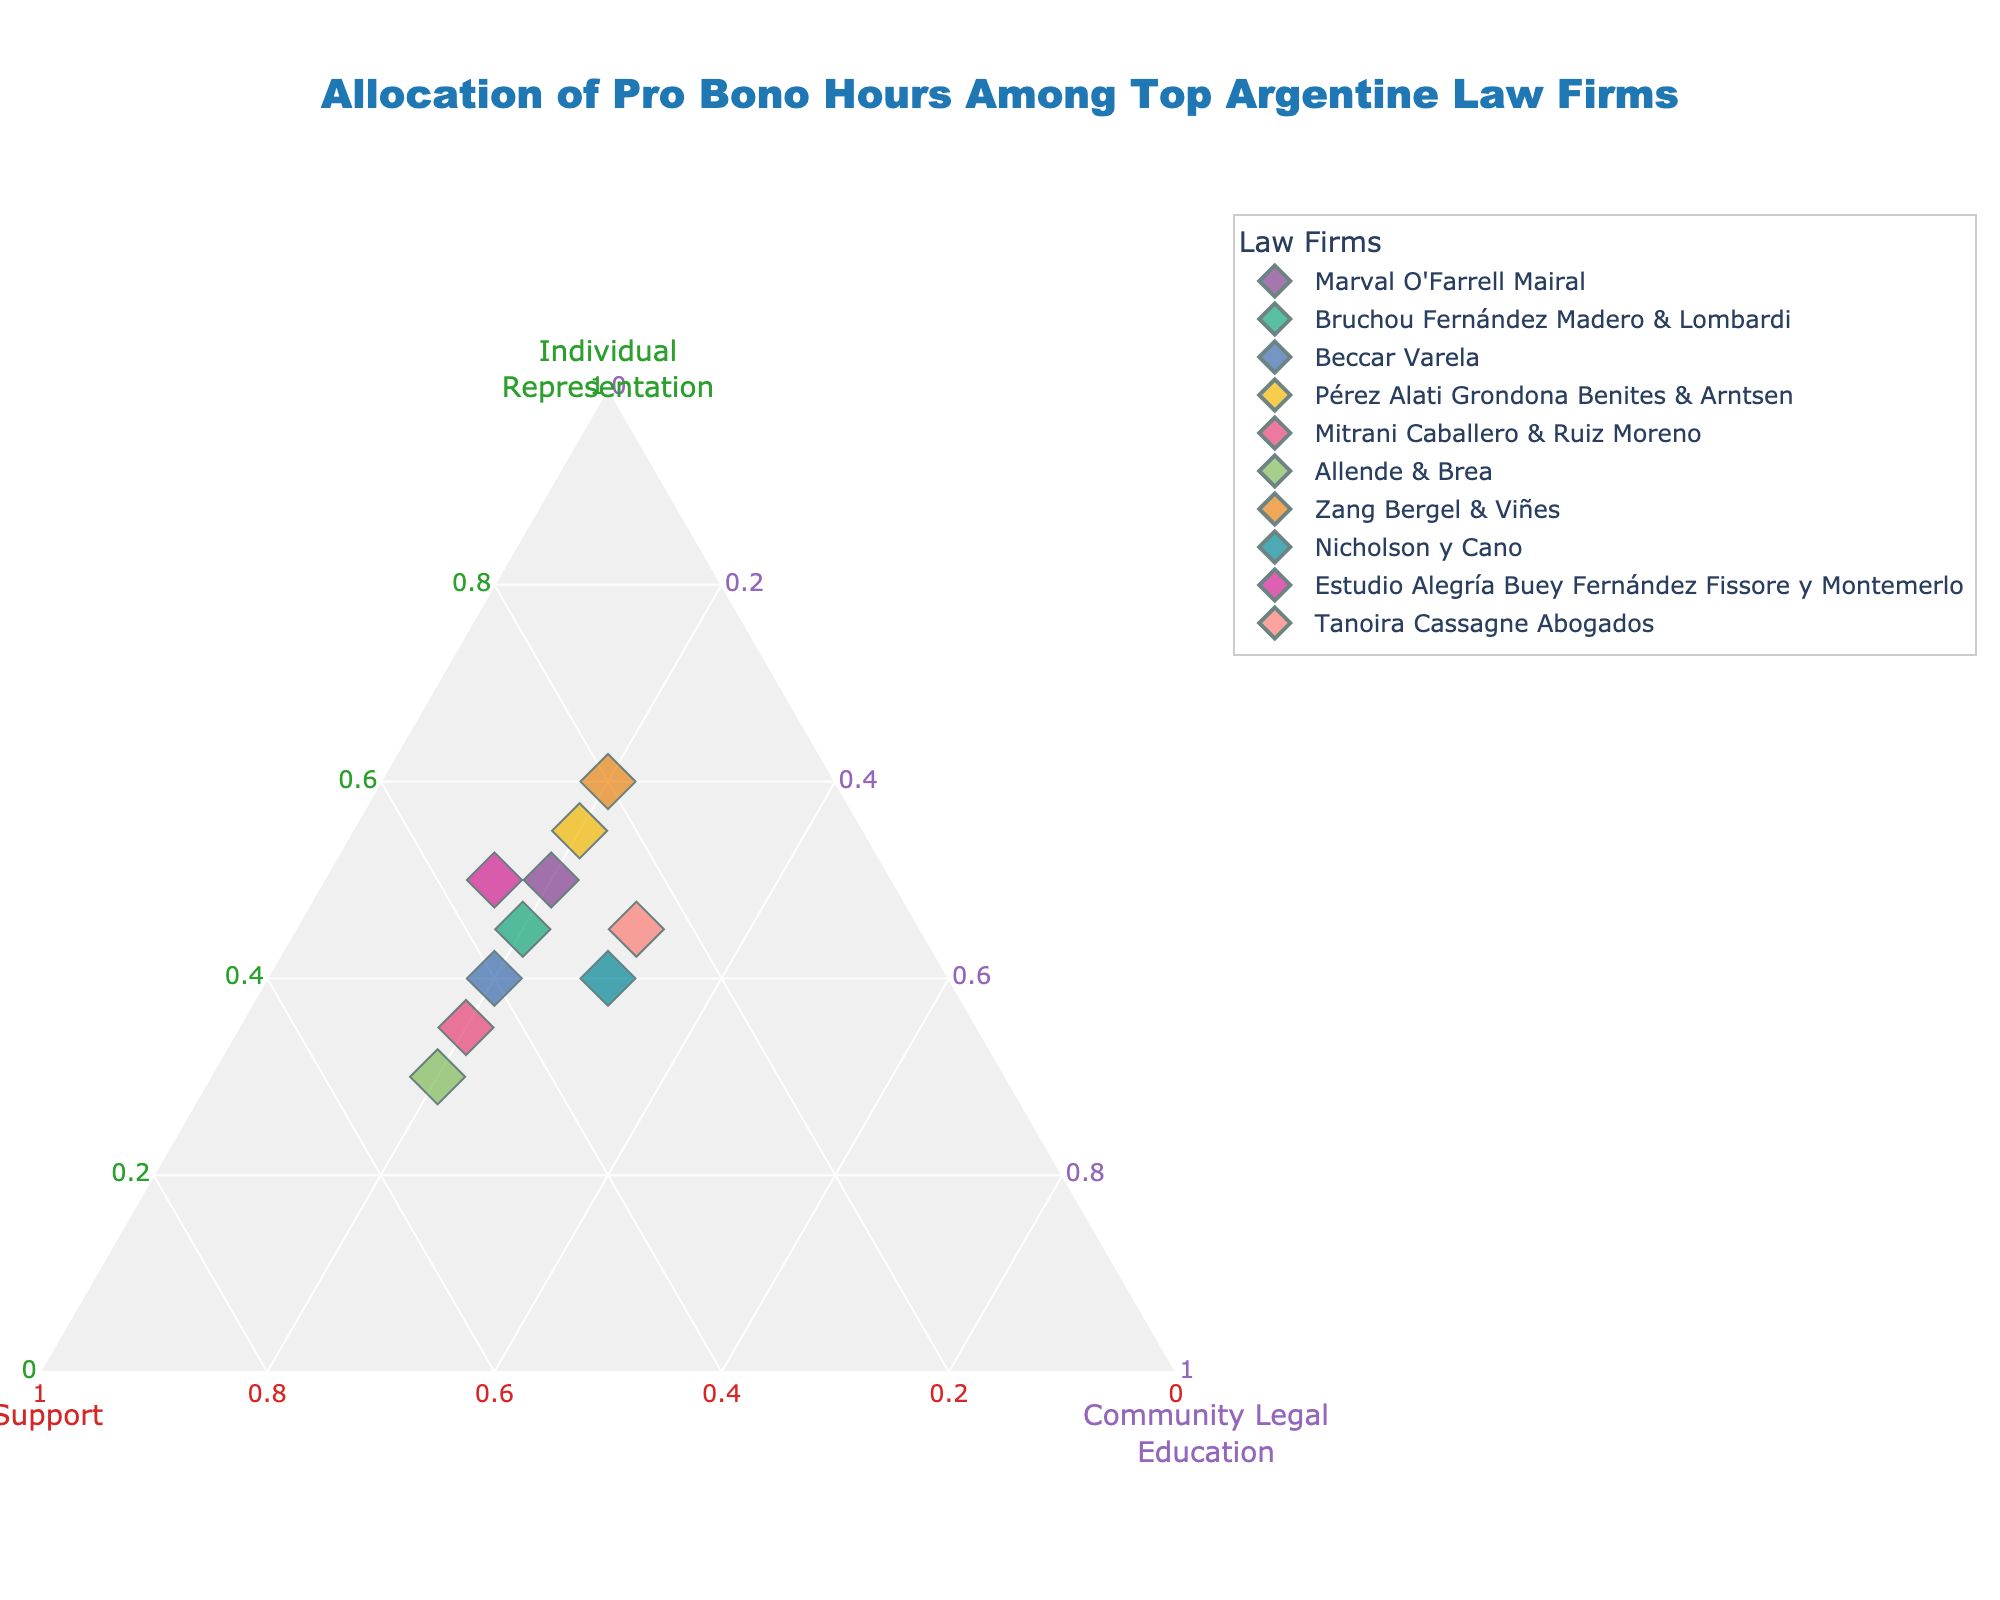What's the title of the figure? The title is displayed at the top of the figure in a prominent font. The text is clearly visible and usually placed centrally.
Answer: Allocation of Pro Bono Hours Among Top Argentine Law Firms Which axis represents 'Individual Representation'? The ternary plot's axis titles are visible. The label on the axis with the title 'Individual Representation' is the one of interest.
Answer: The left axis Which law firm has the highest allocation for 'Individual Representation'? By looking at the points on the ternary plot, identify the point that is closest to the axis representing 'Individual Representation'. The highest value will be the point farthest from this axis.
Answer: Zang Bergel & Viñes When focusing on 'NGO Support', which law firm shows the highest commitment? On the ternary plot, the highest allocation for 'NGO Support' will be represented by the point farthest from the axis labeled 'NGO Support'.
Answer: Allende & Brea Can you identify the law firm with an equal distribution between 'Individual Representation' and 'NGO Support'? Look for a point on the ternary plot that is equally distanced between 'Individual Representation' and 'NGO Support'. The proportions should visually appear equal.
Answer: Beccar Varela How does the allocation of 'Community Legal Education' compare between Nicholson y Cano and Mitrani Caballero & Ruiz Moreno? Compare the distances of the points representing these firms from the axis labeled 'Community Legal Education'. Verify their positions on the axis.
Answer: Nicholson y Cano has a higher allocation than Mitrani Caballero & Ruiz Moreno Which law firms have an equal allocation of hours for 'Community Legal Education'? Find the points on the ternary plot that lie on the line that represents 20% allocation for 'Community Legal Education'.
Answer: Marval O'Farrell Mairal, Bruchou Fernández Madero & Lombardi, Beccar Varela, Pérez Alati Grondona Benites & Arntsen, Mitrani Caballero & Ruiz Moreno, Allende & Brea, Zang Bergel & Viñes Is there a law firm that allocates more hours to 'Community Legal Education' than to 'Individual Representation'? Compare the positions of the points for each law firm. Look for points where the value on the 'Community Legal Education' side is higher than on the 'Individual Representation' side.
Answer: None What is the total number of law firms represented in the figure? Count the number of distinct points displayed on the ternary plot. Each point corresponds to a law firm.
Answer: 10 Which law firm has the closest allocation split among all three categories? Look for the point that seems nearest to the center of the ternary plot, implying an even distribution across 'Individual Representation', 'NGO Support', and 'Community Legal Education'.
Answer: Nicholson y Cano 